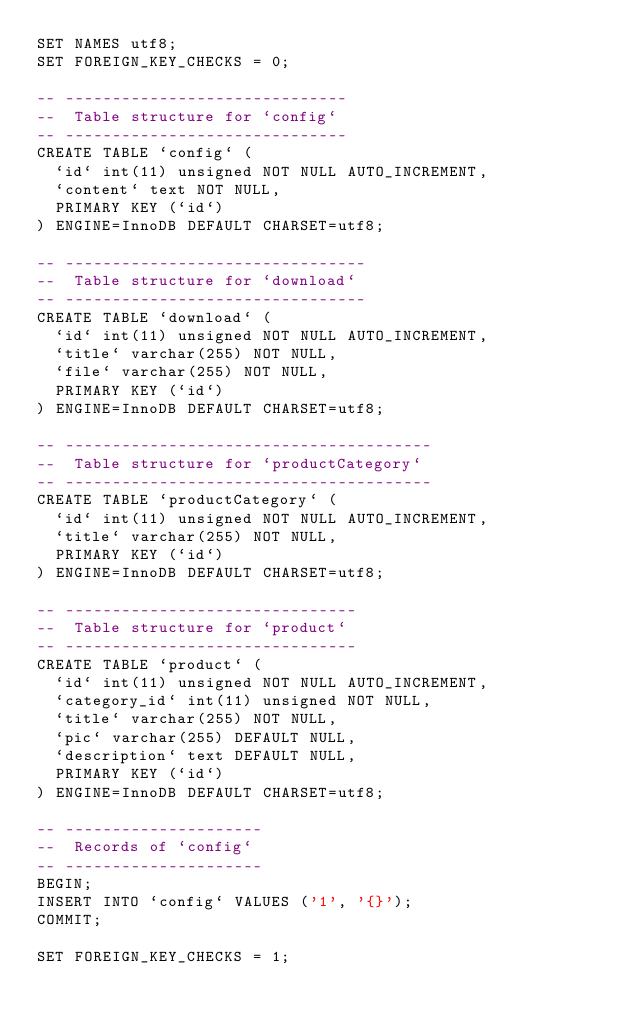Convert code to text. <code><loc_0><loc_0><loc_500><loc_500><_SQL_>SET NAMES utf8;
SET FOREIGN_KEY_CHECKS = 0;

-- ------------------------------
--  Table structure for `config`
-- ------------------------------
CREATE TABLE `config` (
  `id` int(11) unsigned NOT NULL AUTO_INCREMENT,
  `content` text NOT NULL,
  PRIMARY KEY (`id`)
) ENGINE=InnoDB DEFAULT CHARSET=utf8;

-- --------------------------------
--  Table structure for `download`
-- --------------------------------
CREATE TABLE `download` (
  `id` int(11) unsigned NOT NULL AUTO_INCREMENT,
  `title` varchar(255) NOT NULL,
  `file` varchar(255) NOT NULL,
  PRIMARY KEY (`id`)
) ENGINE=InnoDB DEFAULT CHARSET=utf8;

-- ---------------------------------------
--  Table structure for `productCategory`
-- ---------------------------------------
CREATE TABLE `productCategory` (
  `id` int(11) unsigned NOT NULL AUTO_INCREMENT,
  `title` varchar(255) NOT NULL,
  PRIMARY KEY (`id`)
) ENGINE=InnoDB DEFAULT CHARSET=utf8;

-- -------------------------------
--  Table structure for `product`
-- -------------------------------
CREATE TABLE `product` (
  `id` int(11) unsigned NOT NULL AUTO_INCREMENT,
  `category_id` int(11) unsigned NOT NULL,
  `title` varchar(255) NOT NULL,
  `pic` varchar(255) DEFAULT NULL,
  `description` text DEFAULT NULL,
  PRIMARY KEY (`id`)
) ENGINE=InnoDB DEFAULT CHARSET=utf8;

-- ---------------------
--  Records of `config`
-- ---------------------
BEGIN;
INSERT INTO `config` VALUES ('1', '{}');
COMMIT;

SET FOREIGN_KEY_CHECKS = 1;
</code> 